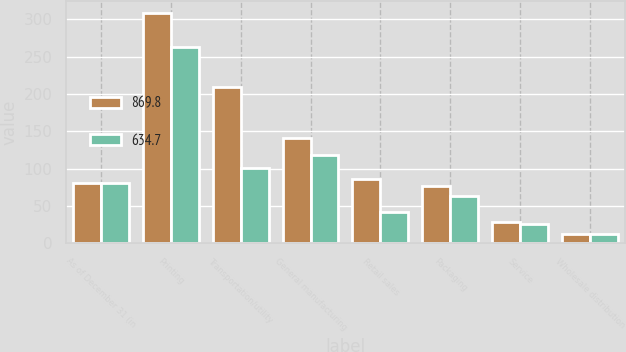Convert chart to OTSL. <chart><loc_0><loc_0><loc_500><loc_500><stacked_bar_chart><ecel><fcel>As of December 31 (in<fcel>Printing<fcel>Transportation/utility<fcel>General manufacturing<fcel>Retail sales<fcel>Packaging<fcel>Service<fcel>Wholesale distribution<nl><fcel>869.8<fcel>81.2<fcel>308.9<fcel>209.5<fcel>141.6<fcel>85.7<fcel>76.7<fcel>28.2<fcel>12.4<nl><fcel>634.7<fcel>81.2<fcel>263<fcel>100.3<fcel>118<fcel>41.5<fcel>63.8<fcel>26.1<fcel>12.4<nl></chart> 